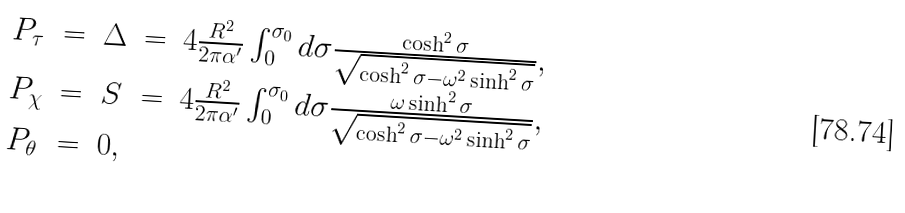Convert formula to latex. <formula><loc_0><loc_0><loc_500><loc_500>\begin{array} { l c c c l } P _ { \tau } & = & \Delta & = & 4 \frac { R ^ { 2 } } { 2 \pi \alpha ^ { \prime } } \int _ { 0 } ^ { \sigma _ { 0 } } d \sigma \frac { \cosh ^ { 2 } \sigma } { \sqrt { \cosh ^ { 2 } \sigma - \omega ^ { 2 } \sinh ^ { 2 } \sigma } } , \\ P _ { \chi } & = & S & = & 4 \frac { R ^ { 2 } } { 2 \pi \alpha ^ { \prime } } \int _ { 0 } ^ { \sigma _ { 0 } } d \sigma \frac { \omega \sinh ^ { 2 } \sigma } { \sqrt { \cosh ^ { 2 } \sigma - \omega ^ { 2 } \sinh ^ { 2 } \sigma } } , \\ P _ { \theta } & = & 0 , & & \end{array}</formula> 